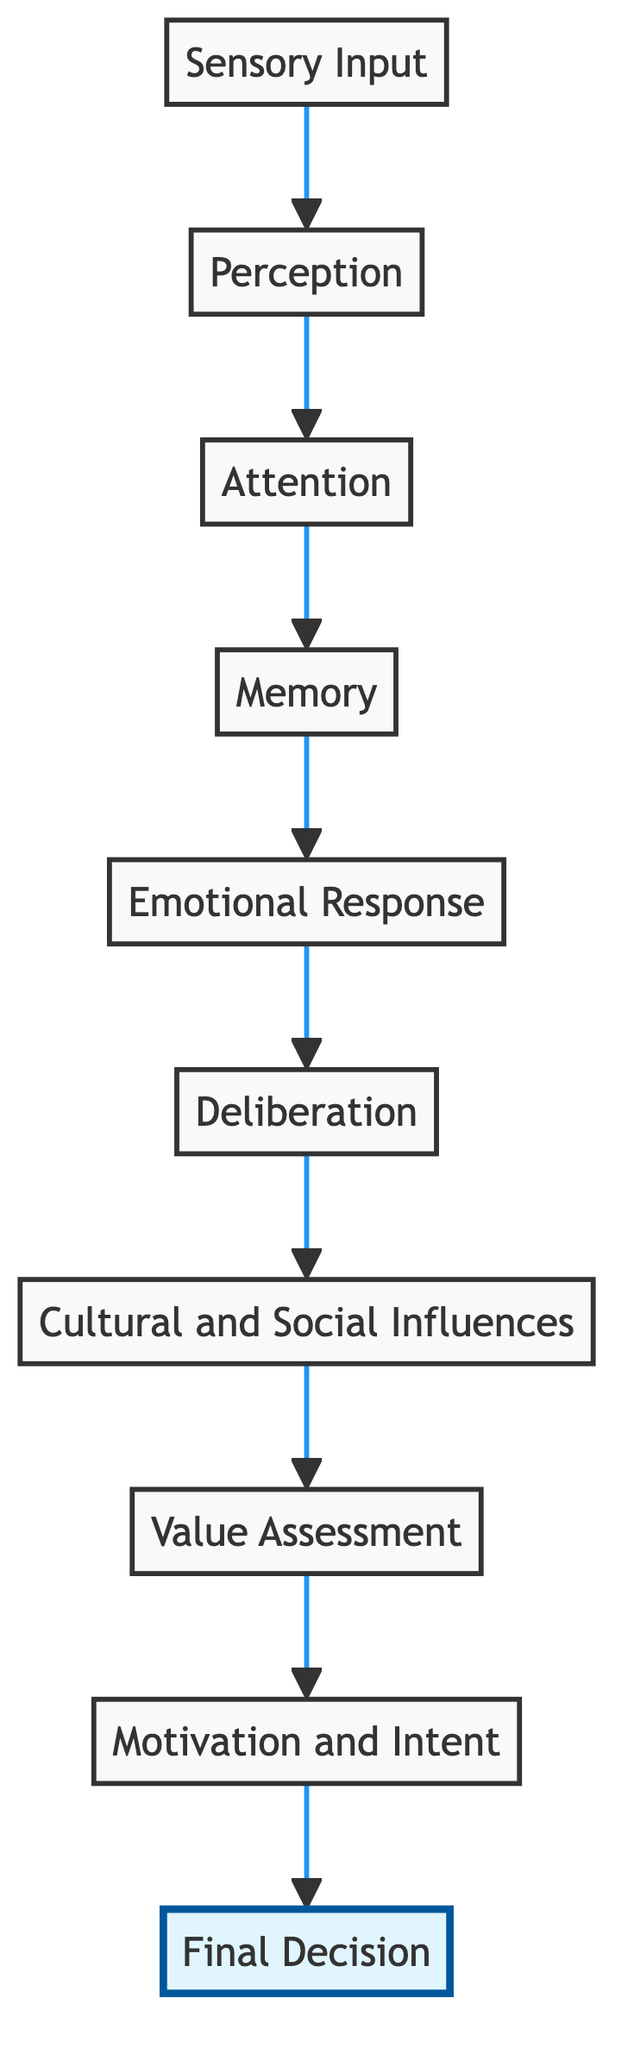What is the final node in the diagram? The flow chart shows a sequence of cognitive processes leading to a conclusion. The last node mentioned after following all connections is named "Final Decision."
Answer: Final Decision How many layers are represented in the flow chart? By counting each unique layer mentioned from "Sensory Input" to "Final Decision," we find a total of ten distinct layers in the flow chart.
Answer: 10 Which node follows "Memory" in the diagram? In the sequence represented in the flow chart, the node directly following "Memory" is "Emotional Response," indicating the next stage in processing cognitive information.
Answer: Emotional Response What is the first layer in the cognitive processes? The diagram starts the flow with "Sensory Input," which is the initial step where raw data is gathered from sensory organs.
Answer: Sensory Input Which process occurs after "Value Assessment"? The process that comes directly after "Value Assessment" in the cognitive decision-making flow is "Motivation and Intent," indicating the consideration of personal drives towards making a decision.
Answer: Motivation and Intent How does "Cultural and Social Influences" affect the final decision? In the sequence shown, "Cultural and Social Influences" is positioned before the "Value Assessment," suggesting it alters how the decision-maker evaluates worth and options, thereby influencing the ultimate choice made at the "Final Decision."
Answer: It influences Value Assessment What is the relationship between "Attention" and "Memory"? "Attention" precedes "Memory" in the flow chart, meaning that focused attention on sensory input allows for better processing and later retrieval of memories. This highlights the importance of attention in effective memory creation.
Answer: Attention precedes Memory What type of influences are noted in the cognitive flow chart? The diagram identifies "Cultural and Social Influences" as part of the cognitive processes, highlighting the role of societal and cultural factors in decision-making.
Answer: Cultural and Social Influences What is the purpose of the "Deliberation" process? "Deliberation" refers to the conscious thought stage where individuals weigh options and consider various outcomes, contributing to arriving at a reasoned decision thereafter.
Answer: Weighing options and outcomes 